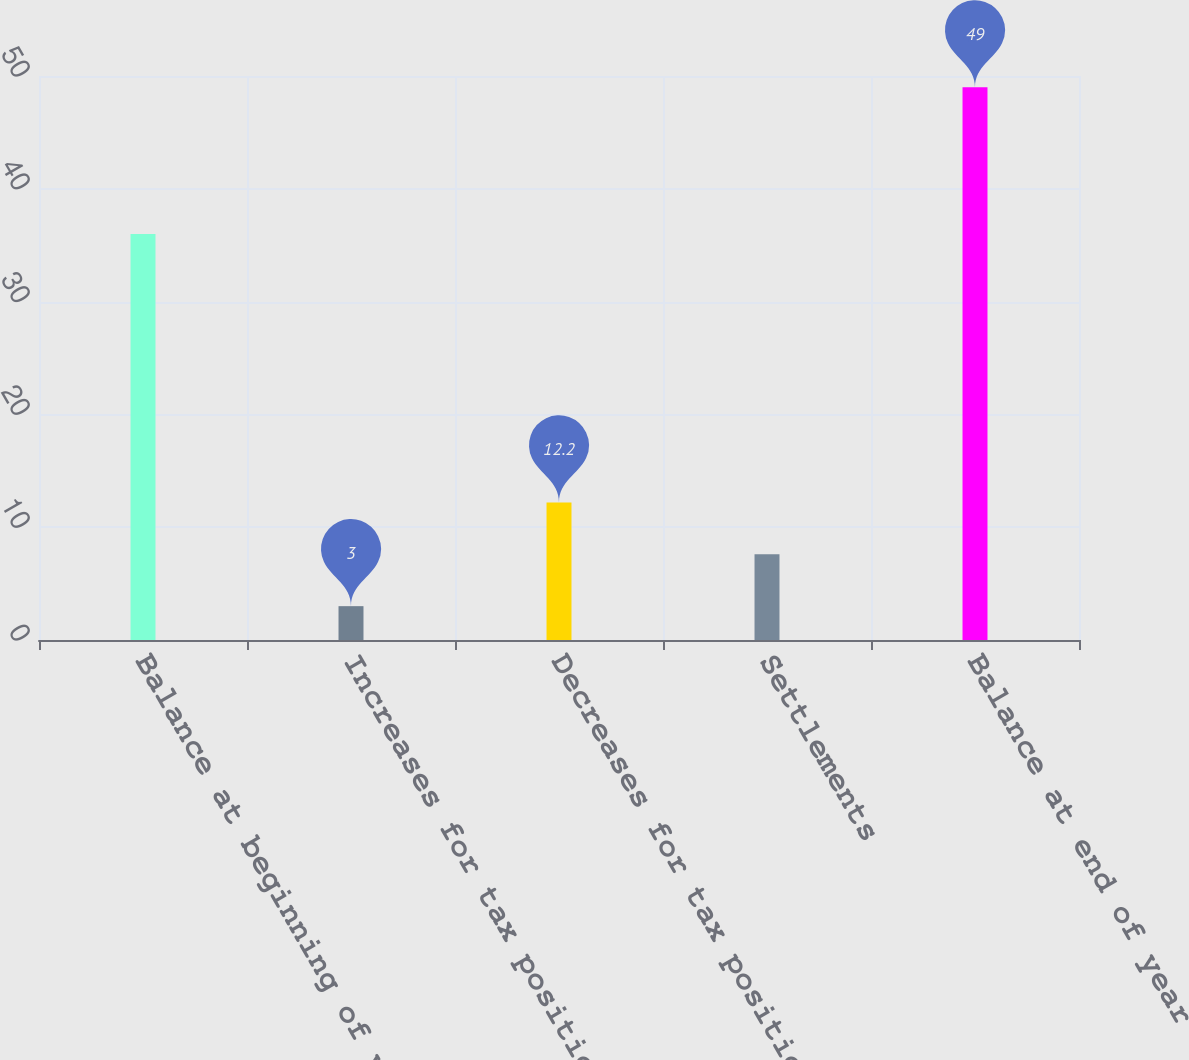<chart> <loc_0><loc_0><loc_500><loc_500><bar_chart><fcel>Balance at beginning of year<fcel>Increases for tax positions<fcel>Decreases for tax positions<fcel>Settlements<fcel>Balance at end of year<nl><fcel>36<fcel>3<fcel>12.2<fcel>7.6<fcel>49<nl></chart> 